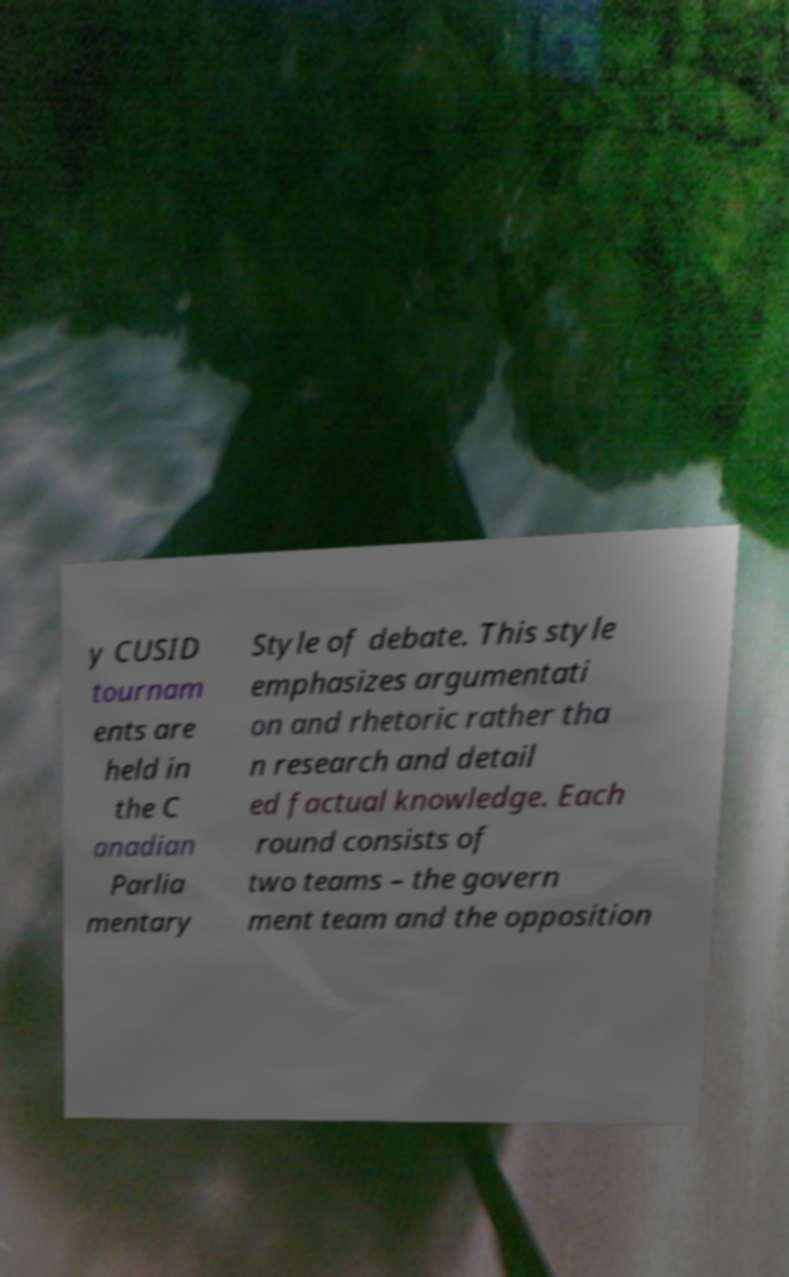Can you accurately transcribe the text from the provided image for me? y CUSID tournam ents are held in the C anadian Parlia mentary Style of debate. This style emphasizes argumentati on and rhetoric rather tha n research and detail ed factual knowledge. Each round consists of two teams – the govern ment team and the opposition 